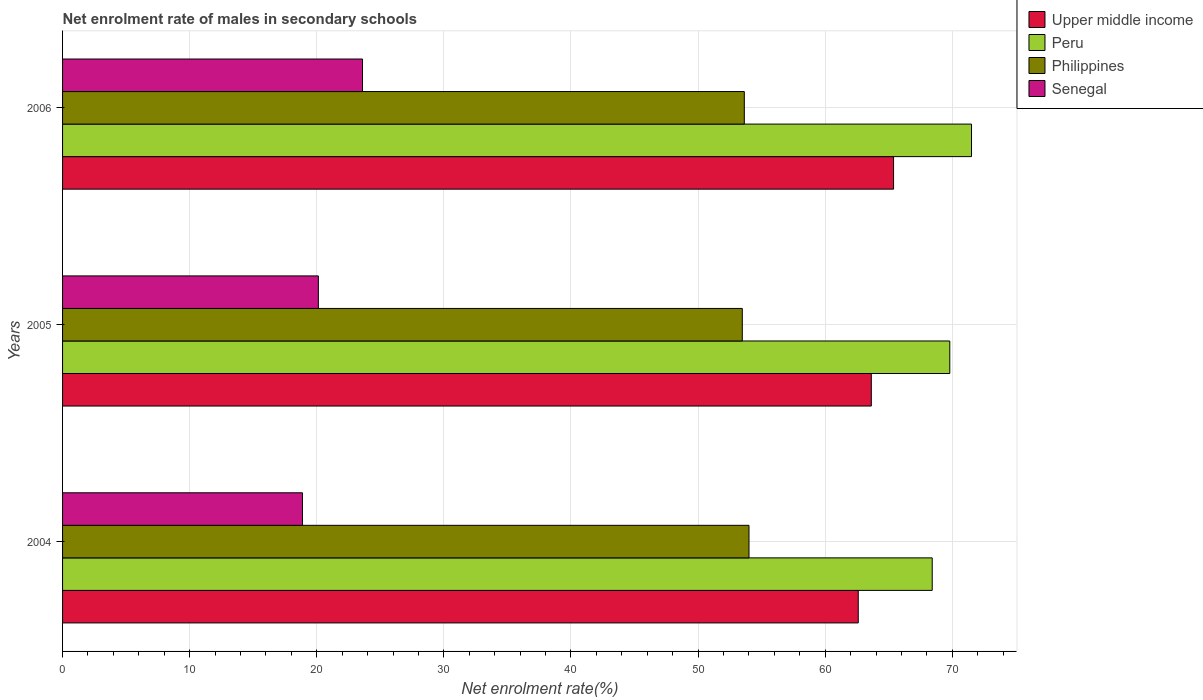How many different coloured bars are there?
Offer a terse response. 4. What is the label of the 2nd group of bars from the top?
Give a very brief answer. 2005. In how many cases, is the number of bars for a given year not equal to the number of legend labels?
Keep it short and to the point. 0. What is the net enrolment rate of males in secondary schools in Upper middle income in 2006?
Make the answer very short. 65.38. Across all years, what is the maximum net enrolment rate of males in secondary schools in Senegal?
Offer a terse response. 23.6. Across all years, what is the minimum net enrolment rate of males in secondary schools in Philippines?
Your answer should be compact. 53.48. In which year was the net enrolment rate of males in secondary schools in Upper middle income minimum?
Offer a terse response. 2004. What is the total net enrolment rate of males in secondary schools in Philippines in the graph?
Give a very brief answer. 161.12. What is the difference between the net enrolment rate of males in secondary schools in Upper middle income in 2004 and that in 2006?
Make the answer very short. -2.78. What is the difference between the net enrolment rate of males in secondary schools in Philippines in 2004 and the net enrolment rate of males in secondary schools in Senegal in 2006?
Give a very brief answer. 30.41. What is the average net enrolment rate of males in secondary schools in Philippines per year?
Keep it short and to the point. 53.71. In the year 2006, what is the difference between the net enrolment rate of males in secondary schools in Senegal and net enrolment rate of males in secondary schools in Peru?
Offer a very short reply. -47.91. In how many years, is the net enrolment rate of males in secondary schools in Upper middle income greater than 58 %?
Your answer should be compact. 3. What is the ratio of the net enrolment rate of males in secondary schools in Senegal in 2005 to that in 2006?
Offer a terse response. 0.85. Is the net enrolment rate of males in secondary schools in Peru in 2004 less than that in 2005?
Ensure brevity in your answer.  Yes. What is the difference between the highest and the second highest net enrolment rate of males in secondary schools in Philippines?
Offer a terse response. 0.37. What is the difference between the highest and the lowest net enrolment rate of males in secondary schools in Senegal?
Provide a short and direct response. 4.73. Is the sum of the net enrolment rate of males in secondary schools in Senegal in 2005 and 2006 greater than the maximum net enrolment rate of males in secondary schools in Upper middle income across all years?
Ensure brevity in your answer.  No. Is it the case that in every year, the sum of the net enrolment rate of males in secondary schools in Upper middle income and net enrolment rate of males in secondary schools in Peru is greater than the sum of net enrolment rate of males in secondary schools in Senegal and net enrolment rate of males in secondary schools in Philippines?
Offer a terse response. No. What does the 1st bar from the bottom in 2006 represents?
Provide a short and direct response. Upper middle income. Are all the bars in the graph horizontal?
Offer a very short reply. Yes. What is the difference between two consecutive major ticks on the X-axis?
Offer a very short reply. 10. Does the graph contain grids?
Make the answer very short. Yes. How are the legend labels stacked?
Your response must be concise. Vertical. What is the title of the graph?
Keep it short and to the point. Net enrolment rate of males in secondary schools. What is the label or title of the X-axis?
Offer a terse response. Net enrolment rate(%). What is the Net enrolment rate(%) in Upper middle income in 2004?
Ensure brevity in your answer.  62.6. What is the Net enrolment rate(%) of Peru in 2004?
Offer a very short reply. 68.42. What is the Net enrolment rate(%) in Philippines in 2004?
Your answer should be compact. 54.01. What is the Net enrolment rate(%) in Senegal in 2004?
Provide a short and direct response. 18.87. What is the Net enrolment rate(%) in Upper middle income in 2005?
Provide a succinct answer. 63.63. What is the Net enrolment rate(%) of Peru in 2005?
Provide a succinct answer. 69.8. What is the Net enrolment rate(%) in Philippines in 2005?
Ensure brevity in your answer.  53.48. What is the Net enrolment rate(%) in Senegal in 2005?
Ensure brevity in your answer.  20.13. What is the Net enrolment rate(%) of Upper middle income in 2006?
Keep it short and to the point. 65.38. What is the Net enrolment rate(%) in Peru in 2006?
Offer a terse response. 71.51. What is the Net enrolment rate(%) in Philippines in 2006?
Ensure brevity in your answer.  53.64. What is the Net enrolment rate(%) of Senegal in 2006?
Make the answer very short. 23.6. Across all years, what is the maximum Net enrolment rate(%) in Upper middle income?
Make the answer very short. 65.38. Across all years, what is the maximum Net enrolment rate(%) of Peru?
Your answer should be very brief. 71.51. Across all years, what is the maximum Net enrolment rate(%) in Philippines?
Make the answer very short. 54.01. Across all years, what is the maximum Net enrolment rate(%) of Senegal?
Provide a short and direct response. 23.6. Across all years, what is the minimum Net enrolment rate(%) in Upper middle income?
Provide a succinct answer. 62.6. Across all years, what is the minimum Net enrolment rate(%) of Peru?
Your response must be concise. 68.42. Across all years, what is the minimum Net enrolment rate(%) in Philippines?
Offer a terse response. 53.48. Across all years, what is the minimum Net enrolment rate(%) of Senegal?
Ensure brevity in your answer.  18.87. What is the total Net enrolment rate(%) in Upper middle income in the graph?
Offer a very short reply. 191.61. What is the total Net enrolment rate(%) of Peru in the graph?
Provide a succinct answer. 209.74. What is the total Net enrolment rate(%) of Philippines in the graph?
Make the answer very short. 161.12. What is the total Net enrolment rate(%) in Senegal in the graph?
Provide a short and direct response. 62.6. What is the difference between the Net enrolment rate(%) of Upper middle income in 2004 and that in 2005?
Give a very brief answer. -1.03. What is the difference between the Net enrolment rate(%) in Peru in 2004 and that in 2005?
Keep it short and to the point. -1.38. What is the difference between the Net enrolment rate(%) in Philippines in 2004 and that in 2005?
Offer a very short reply. 0.53. What is the difference between the Net enrolment rate(%) in Senegal in 2004 and that in 2005?
Your response must be concise. -1.25. What is the difference between the Net enrolment rate(%) in Upper middle income in 2004 and that in 2006?
Your response must be concise. -2.78. What is the difference between the Net enrolment rate(%) of Peru in 2004 and that in 2006?
Offer a very short reply. -3.09. What is the difference between the Net enrolment rate(%) in Philippines in 2004 and that in 2006?
Provide a short and direct response. 0.37. What is the difference between the Net enrolment rate(%) in Senegal in 2004 and that in 2006?
Provide a succinct answer. -4.73. What is the difference between the Net enrolment rate(%) of Upper middle income in 2005 and that in 2006?
Make the answer very short. -1.75. What is the difference between the Net enrolment rate(%) of Peru in 2005 and that in 2006?
Make the answer very short. -1.71. What is the difference between the Net enrolment rate(%) of Philippines in 2005 and that in 2006?
Your response must be concise. -0.16. What is the difference between the Net enrolment rate(%) of Senegal in 2005 and that in 2006?
Keep it short and to the point. -3.47. What is the difference between the Net enrolment rate(%) of Upper middle income in 2004 and the Net enrolment rate(%) of Peru in 2005?
Provide a short and direct response. -7.2. What is the difference between the Net enrolment rate(%) in Upper middle income in 2004 and the Net enrolment rate(%) in Philippines in 2005?
Your response must be concise. 9.12. What is the difference between the Net enrolment rate(%) in Upper middle income in 2004 and the Net enrolment rate(%) in Senegal in 2005?
Provide a short and direct response. 42.48. What is the difference between the Net enrolment rate(%) of Peru in 2004 and the Net enrolment rate(%) of Philippines in 2005?
Your answer should be compact. 14.94. What is the difference between the Net enrolment rate(%) in Peru in 2004 and the Net enrolment rate(%) in Senegal in 2005?
Give a very brief answer. 48.3. What is the difference between the Net enrolment rate(%) in Philippines in 2004 and the Net enrolment rate(%) in Senegal in 2005?
Provide a short and direct response. 33.88. What is the difference between the Net enrolment rate(%) in Upper middle income in 2004 and the Net enrolment rate(%) in Peru in 2006?
Give a very brief answer. -8.91. What is the difference between the Net enrolment rate(%) of Upper middle income in 2004 and the Net enrolment rate(%) of Philippines in 2006?
Your answer should be compact. 8.96. What is the difference between the Net enrolment rate(%) of Upper middle income in 2004 and the Net enrolment rate(%) of Senegal in 2006?
Give a very brief answer. 39. What is the difference between the Net enrolment rate(%) in Peru in 2004 and the Net enrolment rate(%) in Philippines in 2006?
Make the answer very short. 14.78. What is the difference between the Net enrolment rate(%) of Peru in 2004 and the Net enrolment rate(%) of Senegal in 2006?
Give a very brief answer. 44.82. What is the difference between the Net enrolment rate(%) of Philippines in 2004 and the Net enrolment rate(%) of Senegal in 2006?
Offer a terse response. 30.41. What is the difference between the Net enrolment rate(%) in Upper middle income in 2005 and the Net enrolment rate(%) in Peru in 2006?
Provide a succinct answer. -7.88. What is the difference between the Net enrolment rate(%) in Upper middle income in 2005 and the Net enrolment rate(%) in Philippines in 2006?
Offer a very short reply. 9.99. What is the difference between the Net enrolment rate(%) of Upper middle income in 2005 and the Net enrolment rate(%) of Senegal in 2006?
Make the answer very short. 40.03. What is the difference between the Net enrolment rate(%) of Peru in 2005 and the Net enrolment rate(%) of Philippines in 2006?
Give a very brief answer. 16.17. What is the difference between the Net enrolment rate(%) in Peru in 2005 and the Net enrolment rate(%) in Senegal in 2006?
Ensure brevity in your answer.  46.2. What is the difference between the Net enrolment rate(%) of Philippines in 2005 and the Net enrolment rate(%) of Senegal in 2006?
Give a very brief answer. 29.88. What is the average Net enrolment rate(%) of Upper middle income per year?
Provide a short and direct response. 63.87. What is the average Net enrolment rate(%) of Peru per year?
Provide a short and direct response. 69.91. What is the average Net enrolment rate(%) in Philippines per year?
Provide a succinct answer. 53.71. What is the average Net enrolment rate(%) of Senegal per year?
Keep it short and to the point. 20.87. In the year 2004, what is the difference between the Net enrolment rate(%) in Upper middle income and Net enrolment rate(%) in Peru?
Ensure brevity in your answer.  -5.82. In the year 2004, what is the difference between the Net enrolment rate(%) of Upper middle income and Net enrolment rate(%) of Philippines?
Ensure brevity in your answer.  8.6. In the year 2004, what is the difference between the Net enrolment rate(%) of Upper middle income and Net enrolment rate(%) of Senegal?
Provide a short and direct response. 43.73. In the year 2004, what is the difference between the Net enrolment rate(%) of Peru and Net enrolment rate(%) of Philippines?
Ensure brevity in your answer.  14.42. In the year 2004, what is the difference between the Net enrolment rate(%) of Peru and Net enrolment rate(%) of Senegal?
Your answer should be very brief. 49.55. In the year 2004, what is the difference between the Net enrolment rate(%) in Philippines and Net enrolment rate(%) in Senegal?
Provide a succinct answer. 35.13. In the year 2005, what is the difference between the Net enrolment rate(%) in Upper middle income and Net enrolment rate(%) in Peru?
Offer a very short reply. -6.17. In the year 2005, what is the difference between the Net enrolment rate(%) of Upper middle income and Net enrolment rate(%) of Philippines?
Provide a short and direct response. 10.15. In the year 2005, what is the difference between the Net enrolment rate(%) in Upper middle income and Net enrolment rate(%) in Senegal?
Make the answer very short. 43.5. In the year 2005, what is the difference between the Net enrolment rate(%) of Peru and Net enrolment rate(%) of Philippines?
Make the answer very short. 16.33. In the year 2005, what is the difference between the Net enrolment rate(%) of Peru and Net enrolment rate(%) of Senegal?
Your response must be concise. 49.68. In the year 2005, what is the difference between the Net enrolment rate(%) in Philippines and Net enrolment rate(%) in Senegal?
Offer a very short reply. 33.35. In the year 2006, what is the difference between the Net enrolment rate(%) in Upper middle income and Net enrolment rate(%) in Peru?
Your answer should be compact. -6.13. In the year 2006, what is the difference between the Net enrolment rate(%) of Upper middle income and Net enrolment rate(%) of Philippines?
Make the answer very short. 11.74. In the year 2006, what is the difference between the Net enrolment rate(%) in Upper middle income and Net enrolment rate(%) in Senegal?
Your response must be concise. 41.78. In the year 2006, what is the difference between the Net enrolment rate(%) of Peru and Net enrolment rate(%) of Philippines?
Offer a very short reply. 17.88. In the year 2006, what is the difference between the Net enrolment rate(%) in Peru and Net enrolment rate(%) in Senegal?
Provide a succinct answer. 47.91. In the year 2006, what is the difference between the Net enrolment rate(%) in Philippines and Net enrolment rate(%) in Senegal?
Your answer should be compact. 30.04. What is the ratio of the Net enrolment rate(%) of Upper middle income in 2004 to that in 2005?
Provide a succinct answer. 0.98. What is the ratio of the Net enrolment rate(%) in Peru in 2004 to that in 2005?
Make the answer very short. 0.98. What is the ratio of the Net enrolment rate(%) of Philippines in 2004 to that in 2005?
Make the answer very short. 1.01. What is the ratio of the Net enrolment rate(%) of Senegal in 2004 to that in 2005?
Ensure brevity in your answer.  0.94. What is the ratio of the Net enrolment rate(%) in Upper middle income in 2004 to that in 2006?
Your answer should be compact. 0.96. What is the ratio of the Net enrolment rate(%) in Peru in 2004 to that in 2006?
Your response must be concise. 0.96. What is the ratio of the Net enrolment rate(%) of Philippines in 2004 to that in 2006?
Provide a succinct answer. 1.01. What is the ratio of the Net enrolment rate(%) in Senegal in 2004 to that in 2006?
Keep it short and to the point. 0.8. What is the ratio of the Net enrolment rate(%) in Upper middle income in 2005 to that in 2006?
Your answer should be very brief. 0.97. What is the ratio of the Net enrolment rate(%) of Peru in 2005 to that in 2006?
Keep it short and to the point. 0.98. What is the ratio of the Net enrolment rate(%) of Senegal in 2005 to that in 2006?
Your response must be concise. 0.85. What is the difference between the highest and the second highest Net enrolment rate(%) of Upper middle income?
Offer a terse response. 1.75. What is the difference between the highest and the second highest Net enrolment rate(%) of Peru?
Provide a short and direct response. 1.71. What is the difference between the highest and the second highest Net enrolment rate(%) of Philippines?
Your response must be concise. 0.37. What is the difference between the highest and the second highest Net enrolment rate(%) of Senegal?
Offer a very short reply. 3.47. What is the difference between the highest and the lowest Net enrolment rate(%) of Upper middle income?
Your response must be concise. 2.78. What is the difference between the highest and the lowest Net enrolment rate(%) in Peru?
Give a very brief answer. 3.09. What is the difference between the highest and the lowest Net enrolment rate(%) in Philippines?
Provide a succinct answer. 0.53. What is the difference between the highest and the lowest Net enrolment rate(%) of Senegal?
Keep it short and to the point. 4.73. 